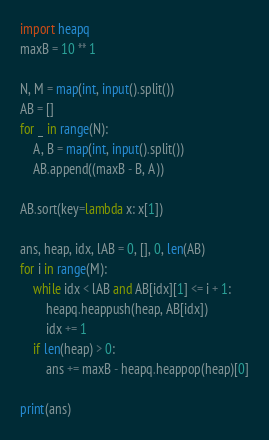Convert code to text. <code><loc_0><loc_0><loc_500><loc_500><_Python_>import heapq
maxB = 10 ** 1

N, M = map(int, input().split())
AB = []
for _ in range(N):
    A, B = map(int, input().split())
    AB.append((maxB - B, A))

AB.sort(key=lambda x: x[1])

ans, heap, idx, lAB = 0, [], 0, len(AB)
for i in range(M):
    while idx < lAB and AB[idx][1] <= i + 1:
        heapq.heappush(heap, AB[idx])
        idx += 1
    if len(heap) > 0:
        ans += maxB - heapq.heappop(heap)[0]

print(ans)
</code> 